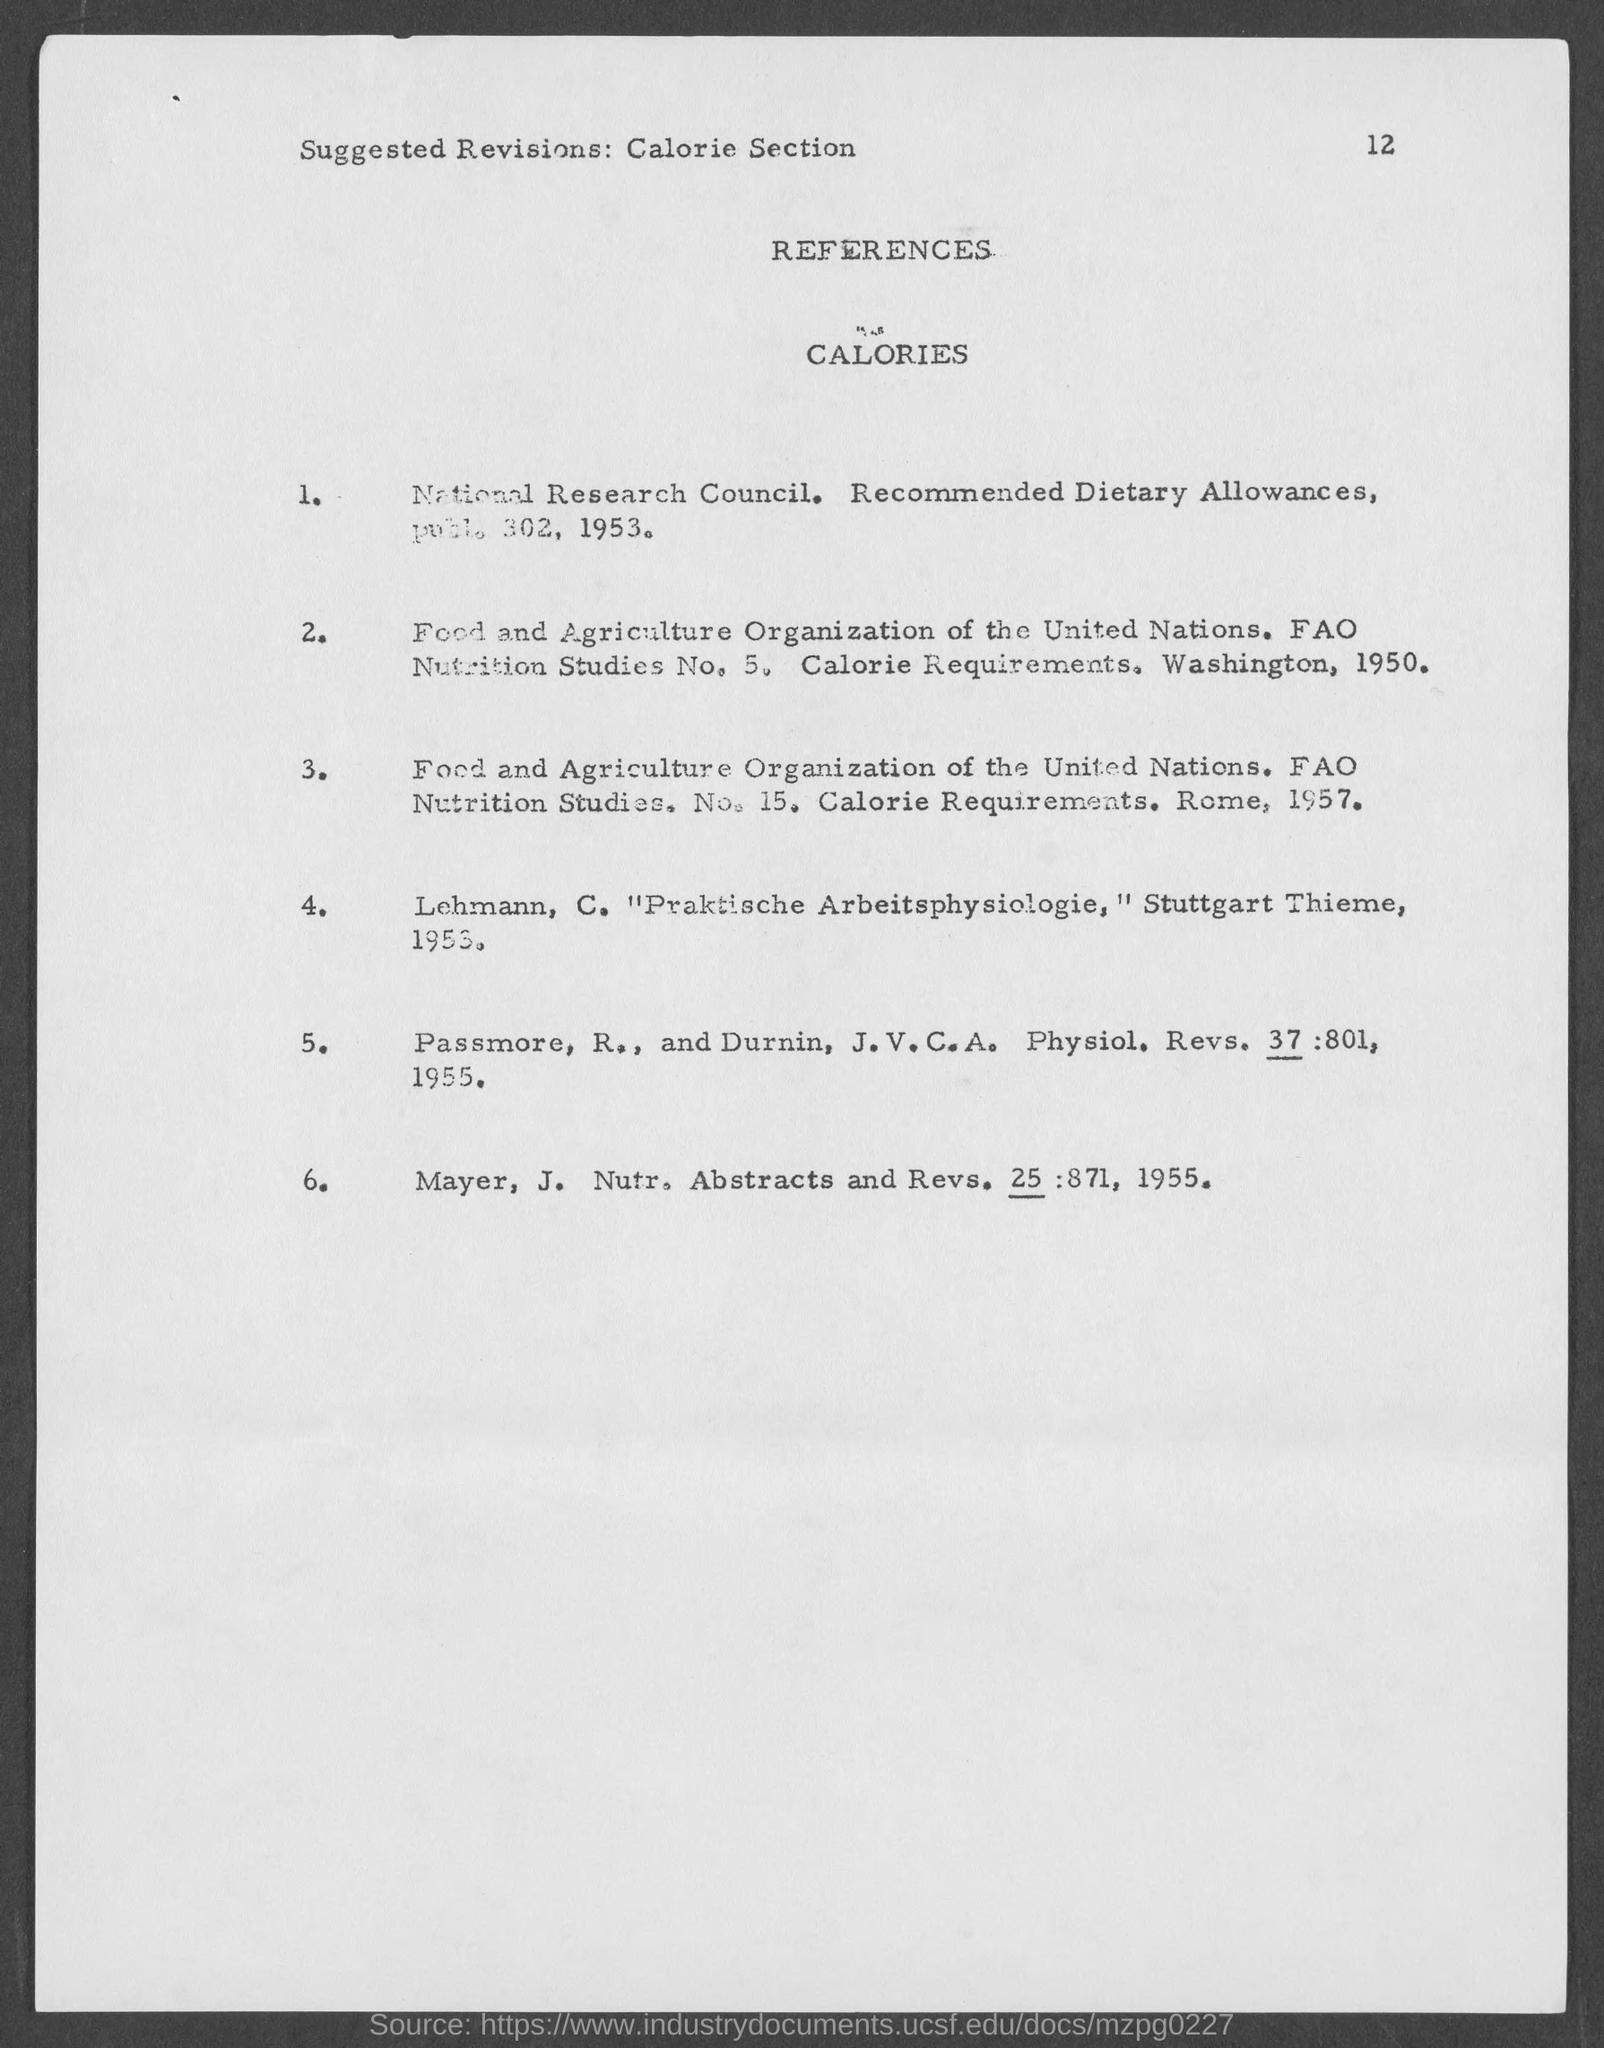Point out several critical features in this image. The page number given in this document is 12. 